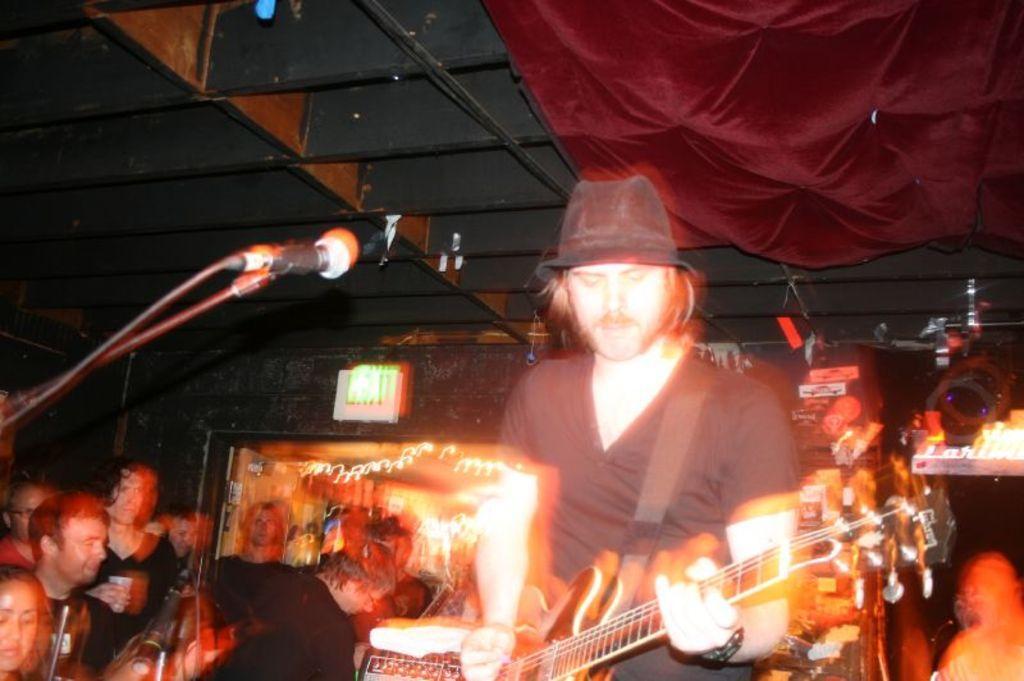How would you summarize this image in a sentence or two? In this image I see a man who is holding the guitar and he is in front of a mic. In the background I see lot of people. 